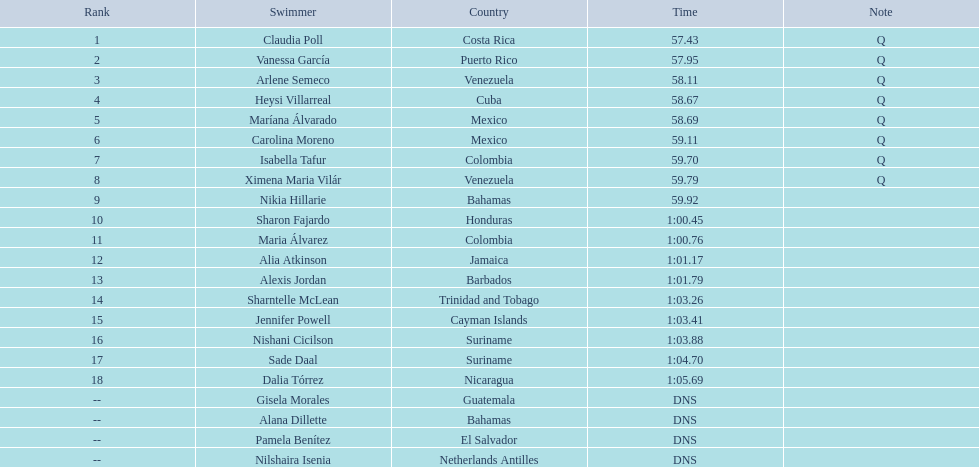Which swimmer had the most extended duration? Dalia Tórrez. 